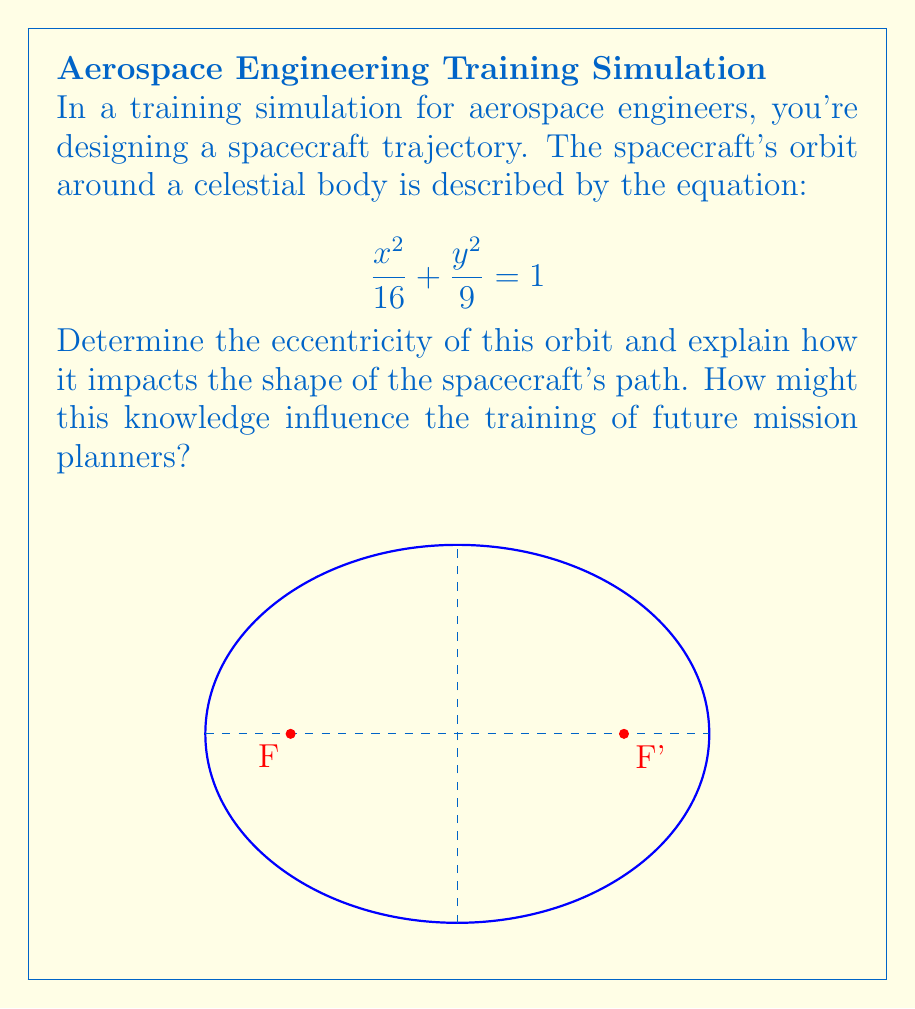Could you help me with this problem? Let's approach this step-by-step:

1) The given equation $\frac{x^2}{16} + \frac{y^2}{9} = 1$ represents an ellipse.

2) For an ellipse, the eccentricity $e$ is defined as:

   $$e = \sqrt{1 - \frac{b^2}{a^2}}$$

   where $a$ is the semi-major axis and $b$ is the semi-minor axis.

3) From the equation, we can identify:
   $a^2 = 16$, so $a = 4$
   $b^2 = 9$, so $b = 3$

4) Substituting these values into the eccentricity formula:

   $$e = \sqrt{1 - \frac{3^2}{4^2}} = \sqrt{1 - \frac{9}{16}} = \sqrt{\frac{7}{16}} \approx 0.661$$

5) The eccentricity of 0.661 indicates an elliptical orbit that is moderately elongated.

6) Eccentricity ranges from 0 to 1 for ellipses:
   - $e = 0$ is a circle
   - $0 < e < 1$ is an ellipse
   - As $e$ approaches 1, the ellipse becomes more elongated

7) This moderate eccentricity implies:
   - The orbit is not circular, but also not extremely elongated
   - The spacecraft will experience varying distances from the celestial body
   - This affects factors like orbital velocity and gravitational influence

8) For training future mission planners:
   - Understanding eccentricity helps in predicting orbital behavior
   - It's crucial for planning fuel consumption, communication windows, and mission timing
   - Adapting training to include various eccentricities prepares planners for diverse mission scenarios
Answer: Eccentricity $e = \sqrt{\frac{7}{16}} \approx 0.661$; moderately elliptical orbit 